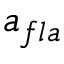Convert formula to latex. <formula><loc_0><loc_0><loc_500><loc_500>a _ { f l a }</formula> 